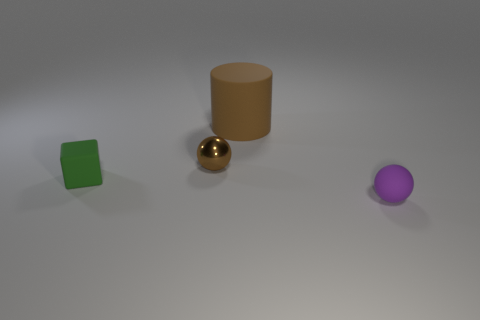Are there any small rubber objects to the right of the large rubber object?
Offer a very short reply. Yes. There is a small thing that is on the left side of the tiny brown object right of the small green matte object; what is its color?
Make the answer very short. Green. Are there fewer big cyan shiny spheres than big matte things?
Provide a short and direct response. Yes. What number of other metallic things are the same shape as the tiny brown object?
Provide a succinct answer. 0. There is a matte object that is the same size as the matte cube; what is its color?
Provide a succinct answer. Purple. Are there the same number of matte things behind the purple sphere and large rubber things that are to the left of the large brown object?
Provide a short and direct response. No. Is there a blue metal thing of the same size as the purple ball?
Provide a succinct answer. No. The block is what size?
Provide a succinct answer. Small. Are there an equal number of brown balls that are to the right of the shiny ball and gray blocks?
Give a very brief answer. Yes. What number of other things are the same color as the small shiny object?
Offer a terse response. 1. 